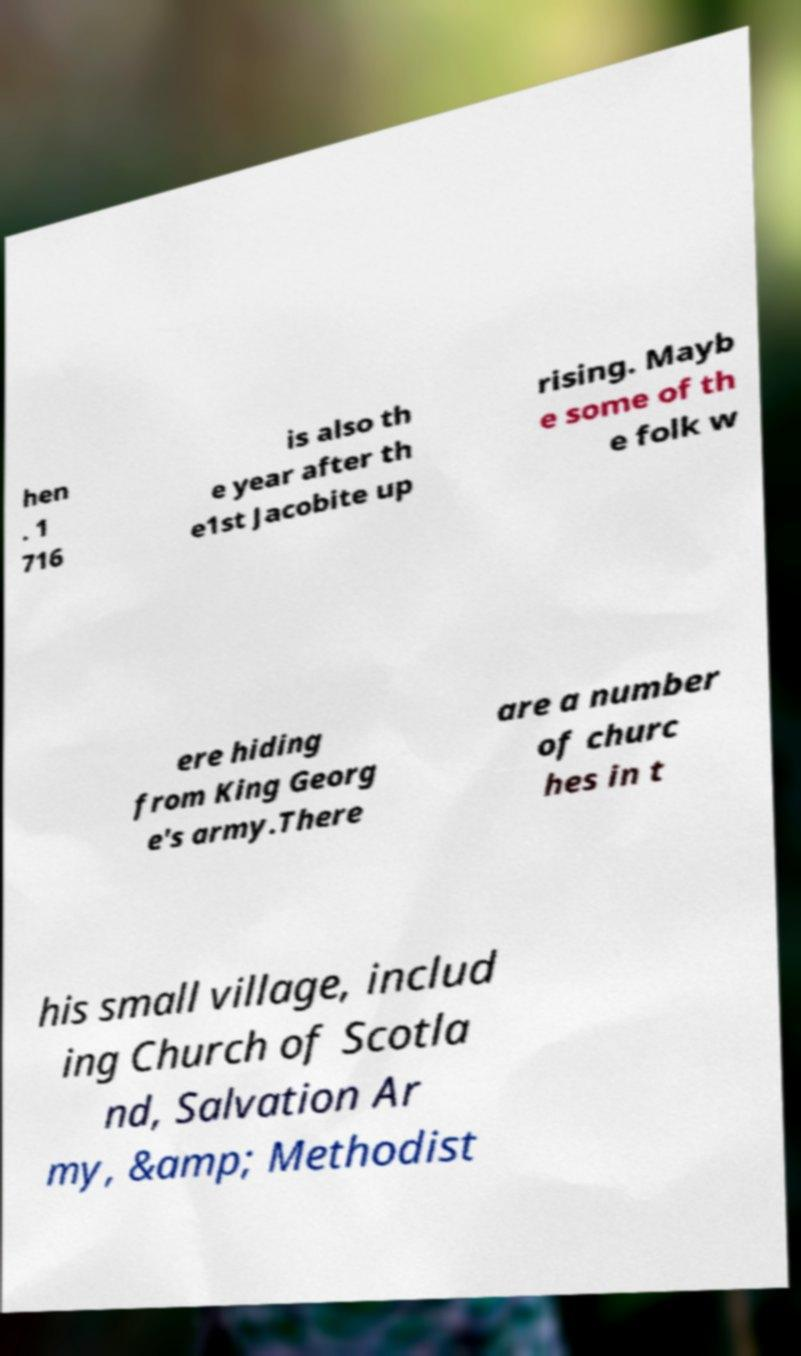Could you assist in decoding the text presented in this image and type it out clearly? hen . 1 716 is also th e year after th e1st Jacobite up rising. Mayb e some of th e folk w ere hiding from King Georg e's army.There are a number of churc hes in t his small village, includ ing Church of Scotla nd, Salvation Ar my, &amp; Methodist 